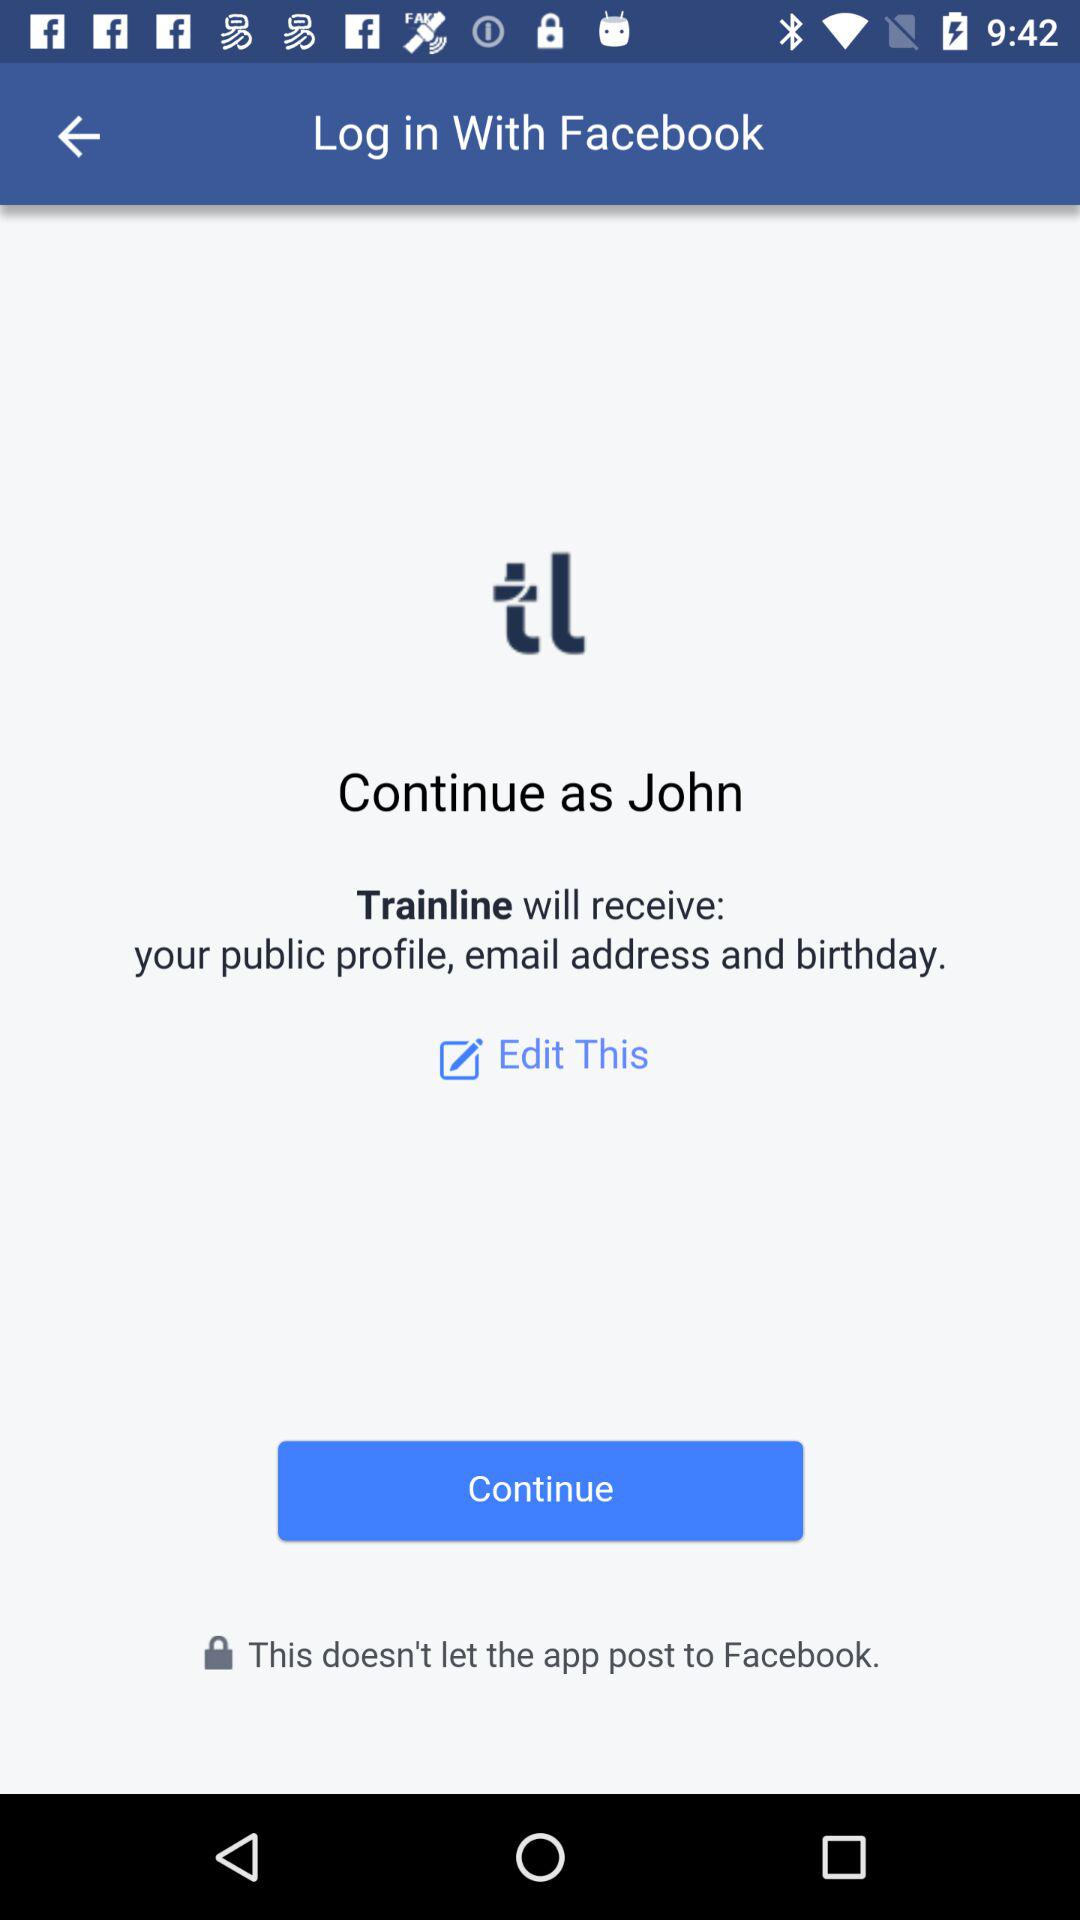What application is asking for permission? The application that is asking for permission is "Trainline". 